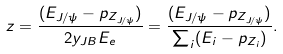<formula> <loc_0><loc_0><loc_500><loc_500>z = \frac { ( E _ { J / \psi } - p _ { Z _ { J / \psi } } ) } { 2 y _ { J B } E _ { e } } = \frac { ( E _ { J / \psi } - p _ { Z _ { J / \psi } } ) } { \sum _ { i } ( E _ { i } - p _ { Z _ { i } } ) } .</formula> 